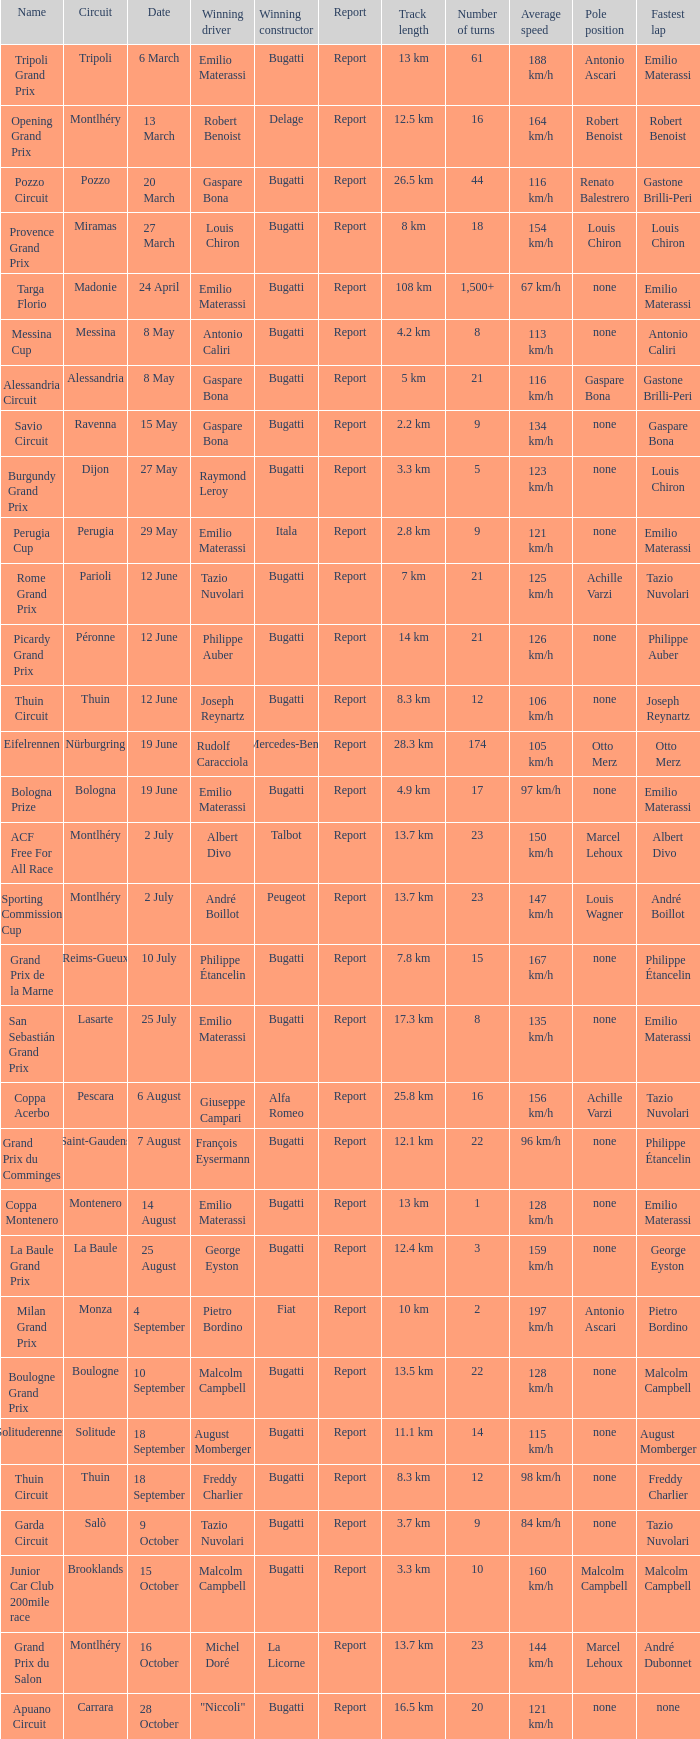Who was the winning constructor at the circuit of parioli? Bugatti. 